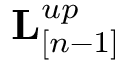<formula> <loc_0><loc_0><loc_500><loc_500>{ L } _ { [ n - 1 ] } ^ { u p }</formula> 